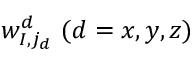Convert formula to latex. <formula><loc_0><loc_0><loc_500><loc_500>w _ { I , j _ { d } } ^ { d } ( d = x , y , z )</formula> 